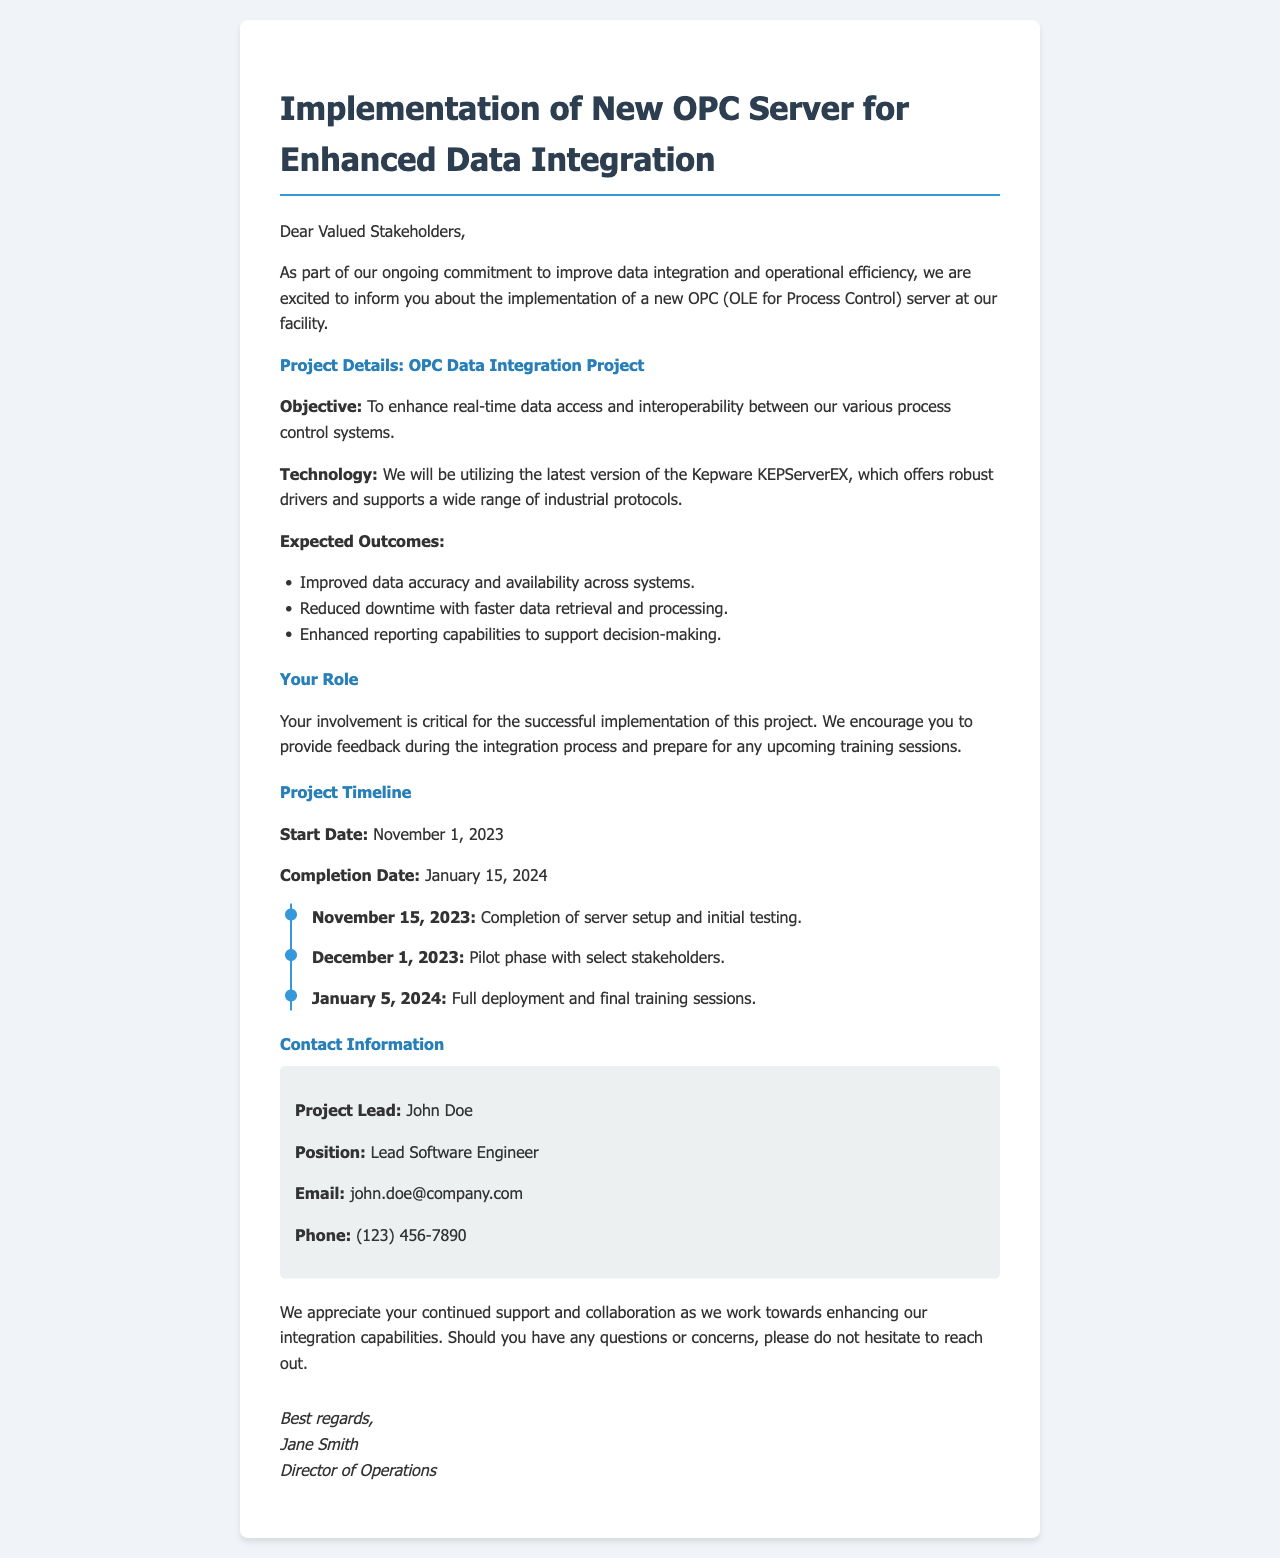what is the launch date of the project? The document states that the project start date is mentioned under the project timeline section.
Answer: November 1, 2023 who is the project lead? The project lead's name is provided in the contact information section.
Answer: John Doe what technology is used for the OPC server? The document mentions the specific technology under project details.
Answer: Kepware KEPServerEX what is the completion date of the project? The completion date is found in the project timeline of the document.
Answer: January 15, 2024 what are stakeholders encouraged to prepare for? This encourages stakeholders for specific preparations mentioned in the document.
Answer: training sessions what is the main objective of the OPC Data Integration Project? The objective is explicitly stated in the document's project details.
Answer: enhance real-time data access how many milestones are there in the project timeline? The number of milestones can be counted from the timeline section.
Answer: Three what is the expected outcome related to data availability? The document lists expected outcomes that include aspects of data availability.
Answer: Improved data accuracy and availability across systems who is the Director of Operations? The name of the Director of Operations is found at the end of the letter.
Answer: Jane Smith 